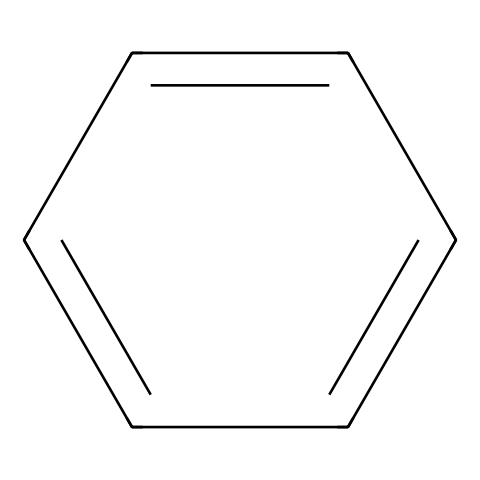What is the molecular formula of the compound represented by the SMILES? The given SMILES denotes a benzene ring, which is a six-carbon cyclic compound with alternating double bonds. The molecular formula is determined by counting the number of carbon (C) and hydrogen (H) atoms. For each carbon atom, there is one hydrogen atom completing the bonds in a cyclic structure. Therefore, the molecular formula is C6H6.
Answer: C6H6 How many carbon atoms are present in this compound? Analyzing the structure from the SMILES, each 'c' represents a carbon atom. There are six 'c' characters, indicating that the compound has six carbon atoms.
Answer: 6 What characteristic feature defines this compound as aromatic? Aromatic compounds are defined by having a cyclic structure with resonance; specifically, they must follow Huckel's rule, which states that there are (4n + 2) π electrons in the compound. In the case of benzene, there are six π electrons due to the alternating double bonds, which confirms its aromatic nature.
Answer: cyclic structure with resonance What is the state of this compound at room temperature? Benzene, before it is turned into polystyrene foam, is typically a liquid at room temperature. This physical state can be concluded from the knowledge that benzene is a known aromatic hydrocarbon with a boiling point of 80.1 °C and a melting point of 5.5 °C.
Answer: liquid Why is the benzene structure significant in materials like polystyrene foam? The benzene structure provides stability and rigidity to polystyrene foam. Polystyrene consists of long chains of this aromatic compound which contribute to strength and thermal stability, important for packaging materials used in gaming headsets. The presence of the benzene ring allows for efficient packing and insulative properties of the foam.
Answer: stability and rigidity How many hydrogen atoms are directly attached to the carbons in this chemical structure? Each carbon in benzene is attached to one hydrogen atom, making it a total of six hydrogen atoms, as there are six carbon atoms in the benzene ring structure. Therefore, we count six hydrogen atoms bonded to these carbons.
Answer: 6 